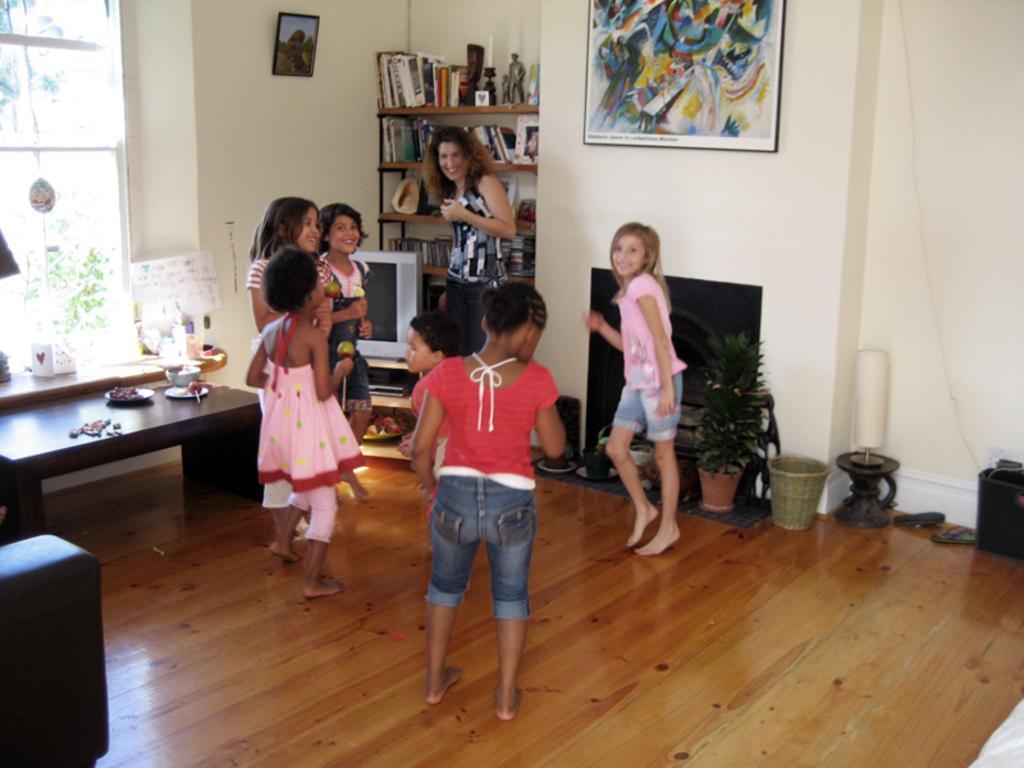Please provide a concise description of this image. This picture is clicked inside a room. There are few girls dancing and a woman standing in image. To the left corner of the image there is a wooden table and on it there are plates and a bowl. Beside to it there is a television and behind the television is a rack and books are placed in it. There is also sculpture in the rack. There are picture frames hanging on the wall. There is a houseplant in the room. In the background there is wall, a window and the floor is furnished with wood. 